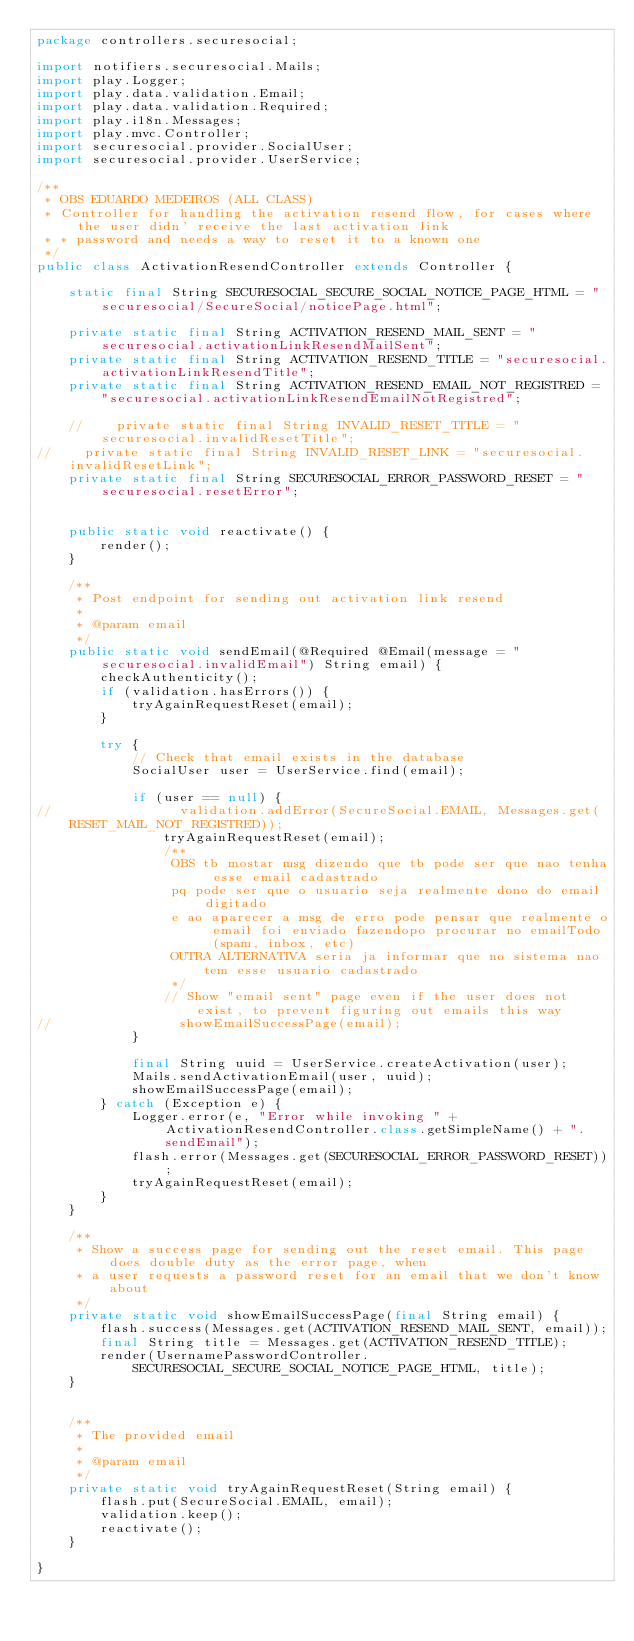<code> <loc_0><loc_0><loc_500><loc_500><_Java_>package controllers.securesocial;

import notifiers.securesocial.Mails;
import play.Logger;
import play.data.validation.Email;
import play.data.validation.Required;
import play.i18n.Messages;
import play.mvc.Controller;
import securesocial.provider.SocialUser;
import securesocial.provider.UserService;

/**
 * OBS EDUARDO MEDEIROS (ALL CLASS)
 * Controller for handling the activation resend flow, for cases where the user didn' receive the last activation link
 * * password and needs a way to reset it to a known one
 */
public class ActivationResendController extends Controller {

    static final String SECURESOCIAL_SECURE_SOCIAL_NOTICE_PAGE_HTML = "securesocial/SecureSocial/noticePage.html";

    private static final String ACTIVATION_RESEND_MAIL_SENT = "securesocial.activationLinkResendMailSent";
    private static final String ACTIVATION_RESEND_TITLE = "securesocial.activationLinkResendTitle";
    private static final String ACTIVATION_RESEND_EMAIL_NOT_REGISTRED = "securesocial.activationLinkResendEmailNotRegistred";

    //    private static final String INVALID_RESET_TITLE = "securesocial.invalidResetTitle";
//    private static final String INVALID_RESET_LINK = "securesocial.invalidResetLink";
    private static final String SECURESOCIAL_ERROR_PASSWORD_RESET = "securesocial.resetError";


    public static void reactivate() {
        render();
    }

    /**
     * Post endpoint for sending out activation link resend
     *
     * @param email
     */
    public static void sendEmail(@Required @Email(message = "securesocial.invalidEmail") String email) {
        checkAuthenticity();
        if (validation.hasErrors()) {
            tryAgainRequestReset(email);
        }

        try {
            // Check that email exists in the database
            SocialUser user = UserService.find(email);

            if (user == null) {
//                validation.addError(SecureSocial.EMAIL, Messages.get(RESET_MAIL_NOT_REGISTRED));
                tryAgainRequestReset(email);
                /**
                 OBS tb mostar msg dizendo que tb pode ser que nao tenha esse email cadastrado
                 pq pode ser que o usuario seja realmente dono do email digitado
                 e ao aparecer a msg de erro pode pensar que realmente o email foi enviado fazendopo procurar no emailTodo (spam, inbox, etc)
                 OUTRA ALTERNATIVA seria ja informar que no sistema nao tem esse usuario cadastrado
                 */
                // Show "email sent" page even if the user does not exist, to prevent figuring out emails this way
//                showEmailSuccessPage(email);
            }

            final String uuid = UserService.createActivation(user);
            Mails.sendActivationEmail(user, uuid);
            showEmailSuccessPage(email);
        } catch (Exception e) {
            Logger.error(e, "Error while invoking " + ActivationResendController.class.getSimpleName() + ".sendEmail");
            flash.error(Messages.get(SECURESOCIAL_ERROR_PASSWORD_RESET));
            tryAgainRequestReset(email);
        }
    }

    /**
     * Show a success page for sending out the reset email. This page does double duty as the error page, when
     * a user requests a password reset for an email that we don't know about
     */
    private static void showEmailSuccessPage(final String email) {
        flash.success(Messages.get(ACTIVATION_RESEND_MAIL_SENT, email));
        final String title = Messages.get(ACTIVATION_RESEND_TITLE);
        render(UsernamePasswordController.SECURESOCIAL_SECURE_SOCIAL_NOTICE_PAGE_HTML, title);
    }


    /**
     * The provided email
     *
     * @param email
     */
    private static void tryAgainRequestReset(String email) {
        flash.put(SecureSocial.EMAIL, email);
        validation.keep();
        reactivate();
    }

}
</code> 